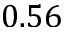Convert formula to latex. <formula><loc_0><loc_0><loc_500><loc_500>0 . 5 6</formula> 